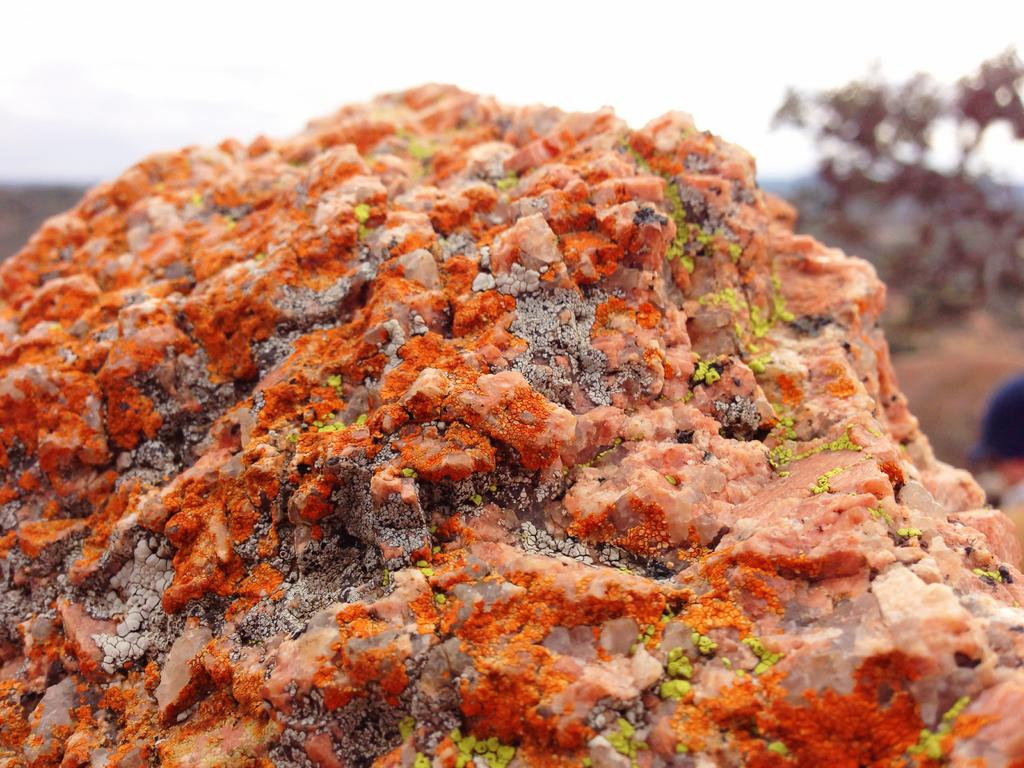What is the main subject in the image? There is a rock in the image. What is the condition of the sky in the image? The sky is cloudy in the image. What type of vegetation is on the right side of the image? There is a tree on the right side of the image. What type of toothpaste is the rock using in the image? There is no toothpaste present in the image, as rocks do not use toothpaste. 